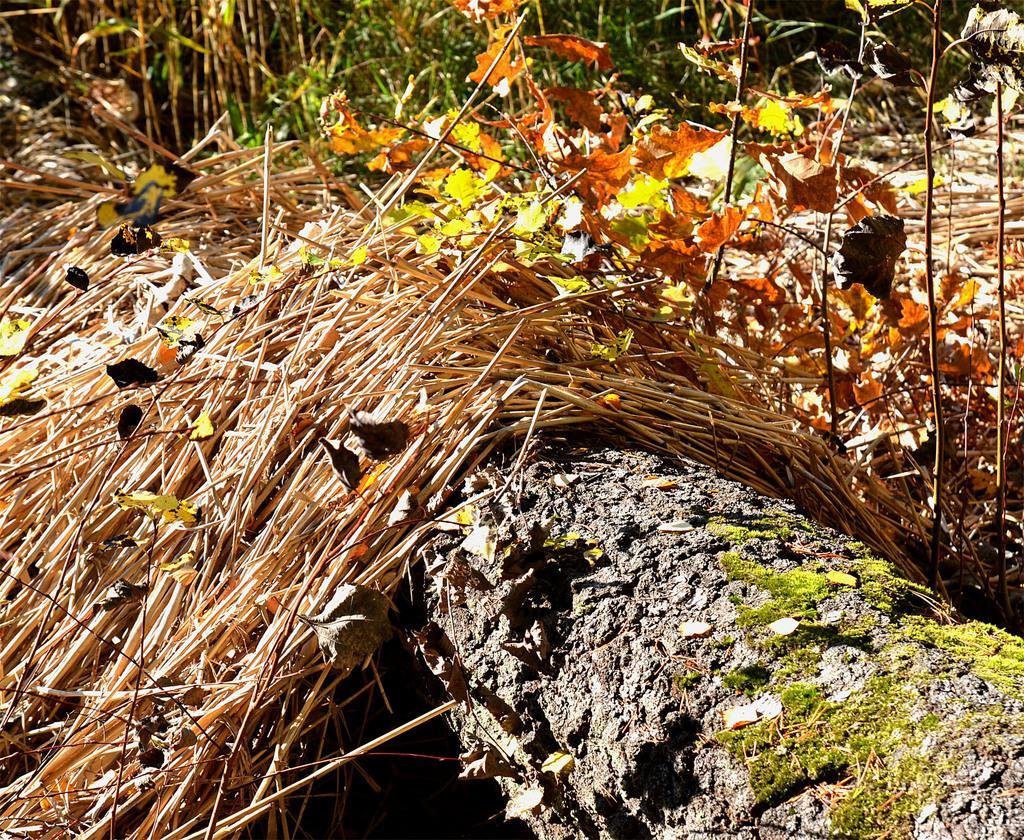Please provide a concise description of this image. In this image we can see some plants, wooden sticks and an object, which looks like a trunk. 